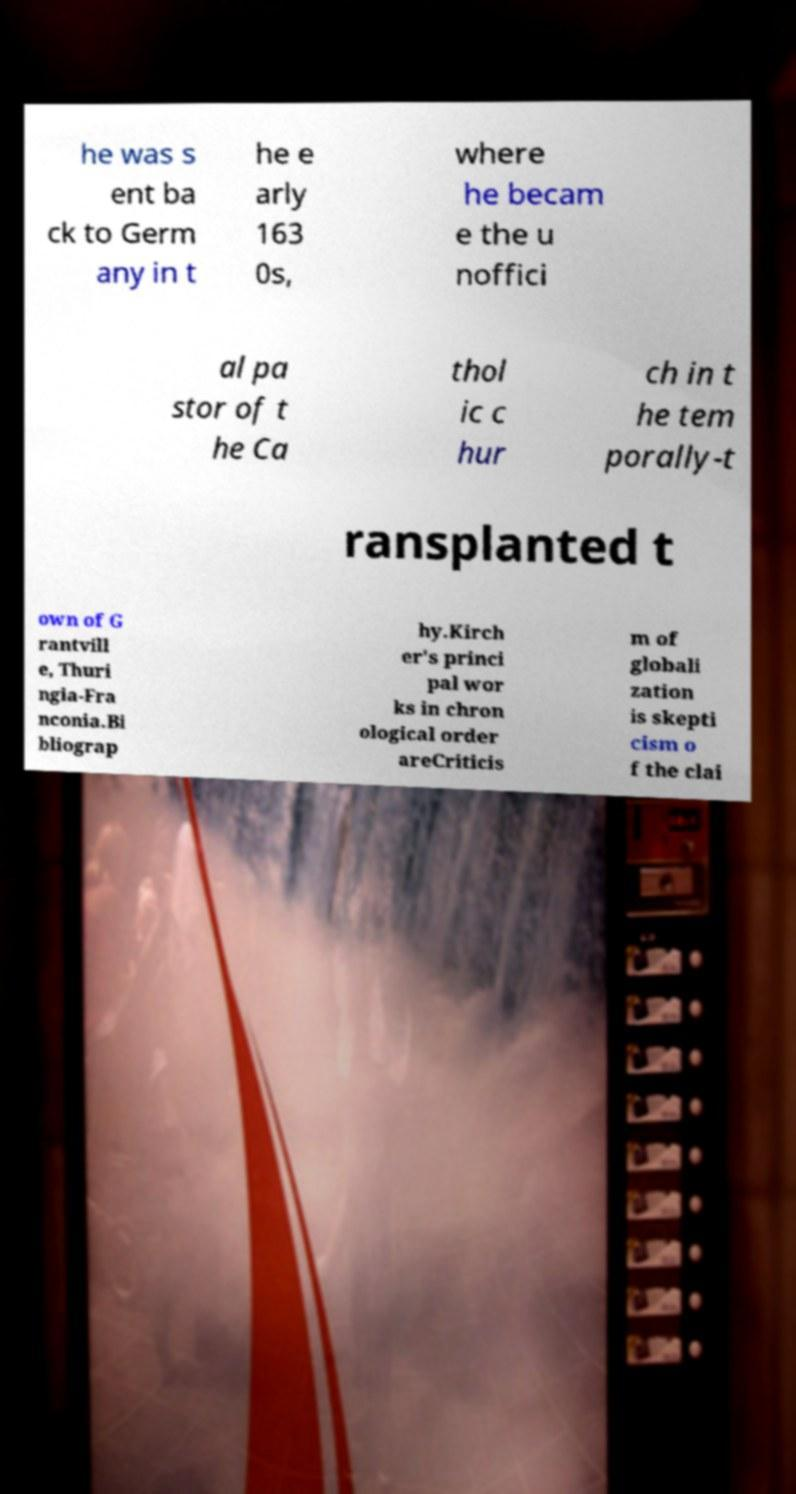Please identify and transcribe the text found in this image. he was s ent ba ck to Germ any in t he e arly 163 0s, where he becam e the u noffici al pa stor of t he Ca thol ic c hur ch in t he tem porally-t ransplanted t own of G rantvill e, Thuri ngia-Fra nconia.Bi bliograp hy.Kirch er's princi pal wor ks in chron ological order areCriticis m of globali zation is skepti cism o f the clai 